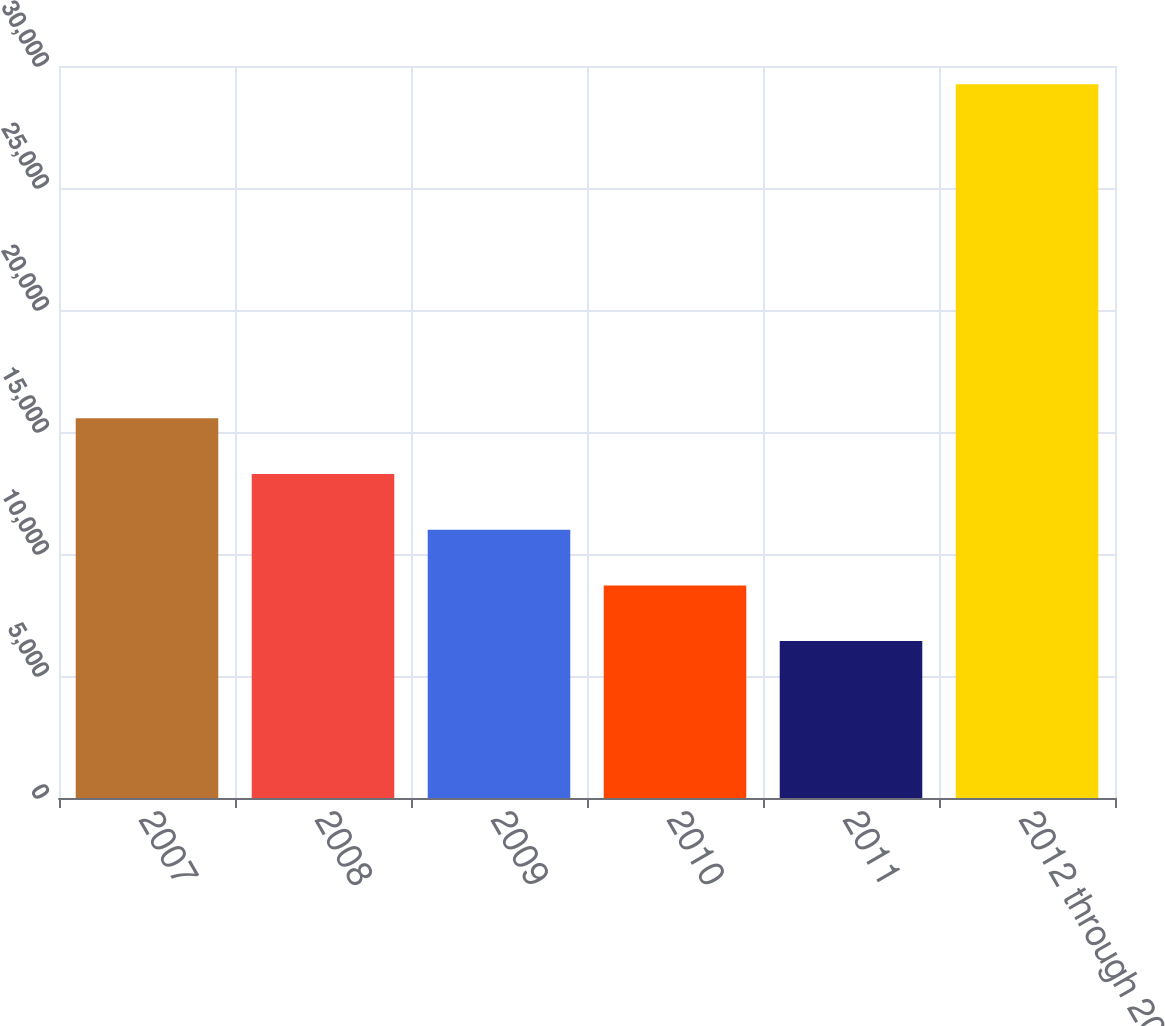<chart> <loc_0><loc_0><loc_500><loc_500><bar_chart><fcel>2007<fcel>2008<fcel>2009<fcel>2010<fcel>2011<fcel>2012 through 2016<nl><fcel>15558.6<fcel>13276.7<fcel>10994.8<fcel>8712.9<fcel>6431<fcel>29250<nl></chart> 